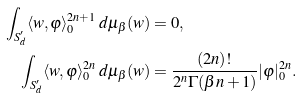<formula> <loc_0><loc_0><loc_500><loc_500>\int _ { S ^ { \prime } _ { d } } \langle w , \varphi \rangle _ { 0 } ^ { 2 n + 1 } \, d \mu _ { \beta } ( w ) & = 0 , \\ \int _ { S ^ { \prime } _ { d } } \langle w , \varphi \rangle _ { 0 } ^ { 2 n } \, d \mu _ { \beta } ( w ) & = \frac { ( 2 n ) ! } { 2 ^ { n } \Gamma ( \beta n + 1 ) } | \varphi | _ { 0 } ^ { 2 n } .</formula> 